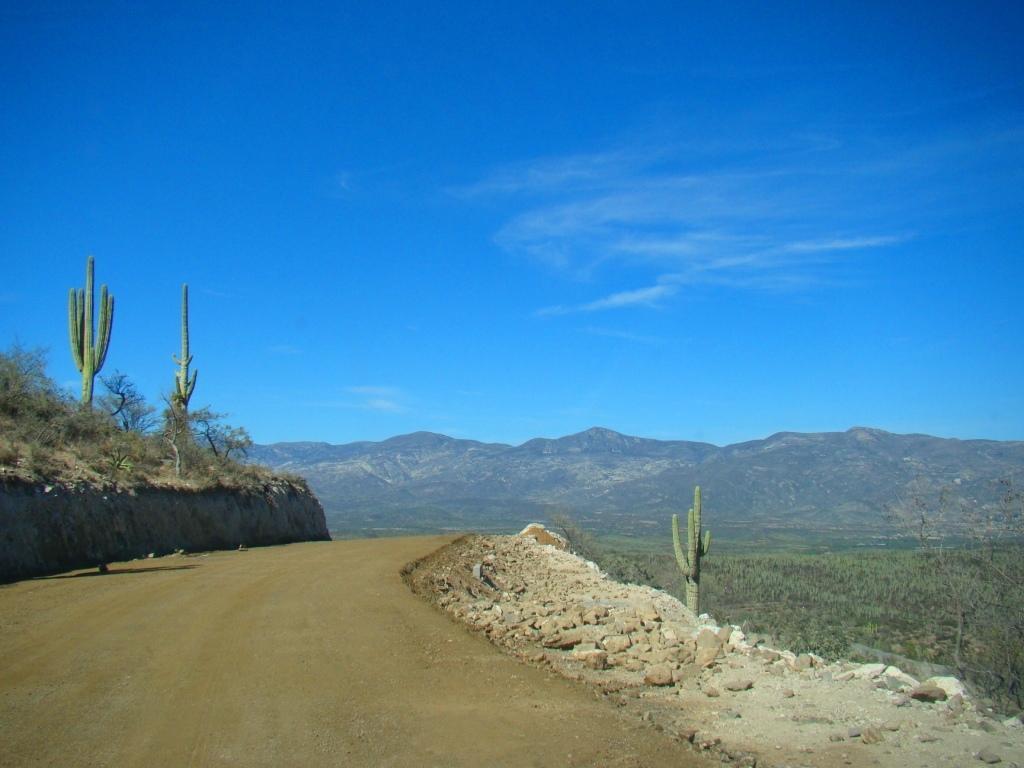Could you give a brief overview of what you see in this image? This picture is taken from the outside of the city. In this image, on the right side, we can see some plants, stones. On the left side, we can see some trees, plants, rocks. In the background, we can see some rocks, trees, plants. At the top, we can see a sky which is in blue color, at the bottom, we can see some grass and a land with some stones. 